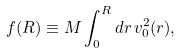Convert formula to latex. <formula><loc_0><loc_0><loc_500><loc_500>f ( R ) \equiv M \int _ { 0 } ^ { R } d r \, v _ { 0 } ^ { 2 } ( r ) ,</formula> 